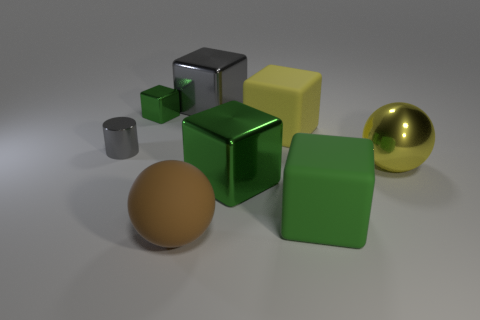Subtract all green cubes. How many were subtracted if there are1green cubes left? 2 Add 1 small green shiny things. How many objects exist? 9 Subtract all spheres. How many objects are left? 6 Subtract all brown balls. How many balls are left? 1 Subtract all big yellow rubber cubes. How many cubes are left? 4 Subtract 1 blocks. How many blocks are left? 4 Subtract all red cubes. Subtract all red balls. How many cubes are left? 5 Subtract all green cubes. How many yellow balls are left? 1 Subtract all rubber objects. Subtract all brown things. How many objects are left? 4 Add 2 large objects. How many large objects are left? 8 